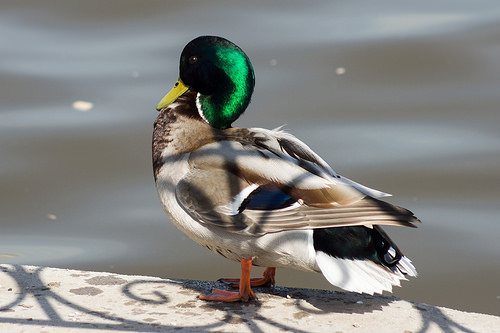<image>
Can you confirm if the shadow is on the duck? Yes. Looking at the image, I can see the shadow is positioned on top of the duck, with the duck providing support. 